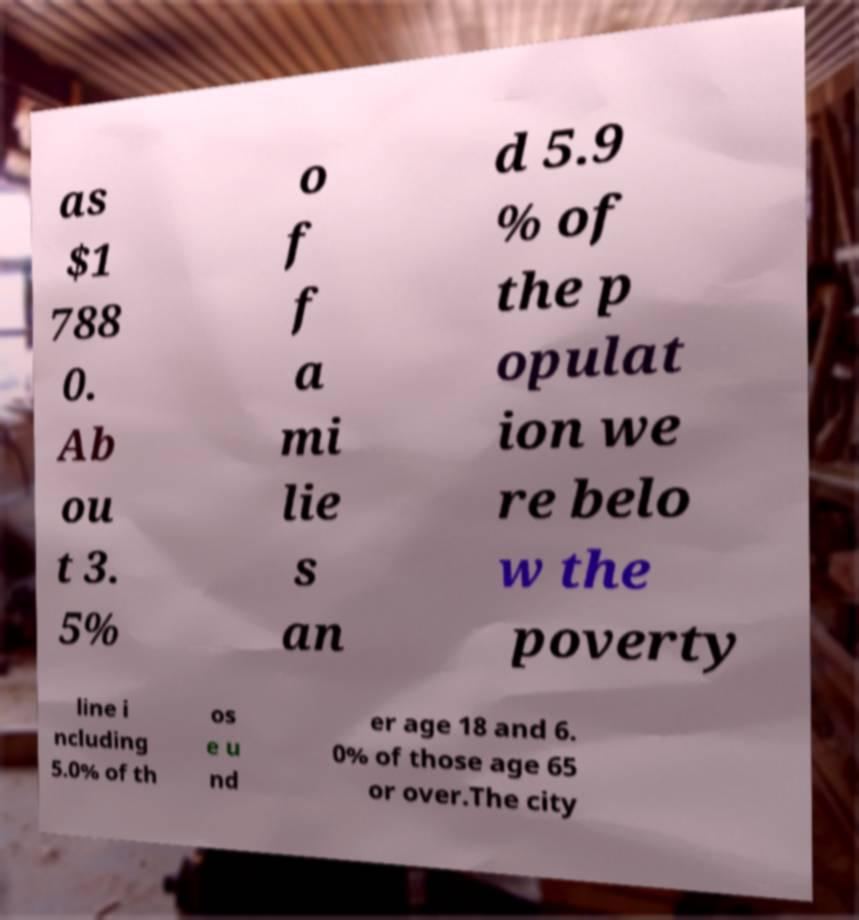Can you accurately transcribe the text from the provided image for me? as $1 788 0. Ab ou t 3. 5% o f f a mi lie s an d 5.9 % of the p opulat ion we re belo w the poverty line i ncluding 5.0% of th os e u nd er age 18 and 6. 0% of those age 65 or over.The city 